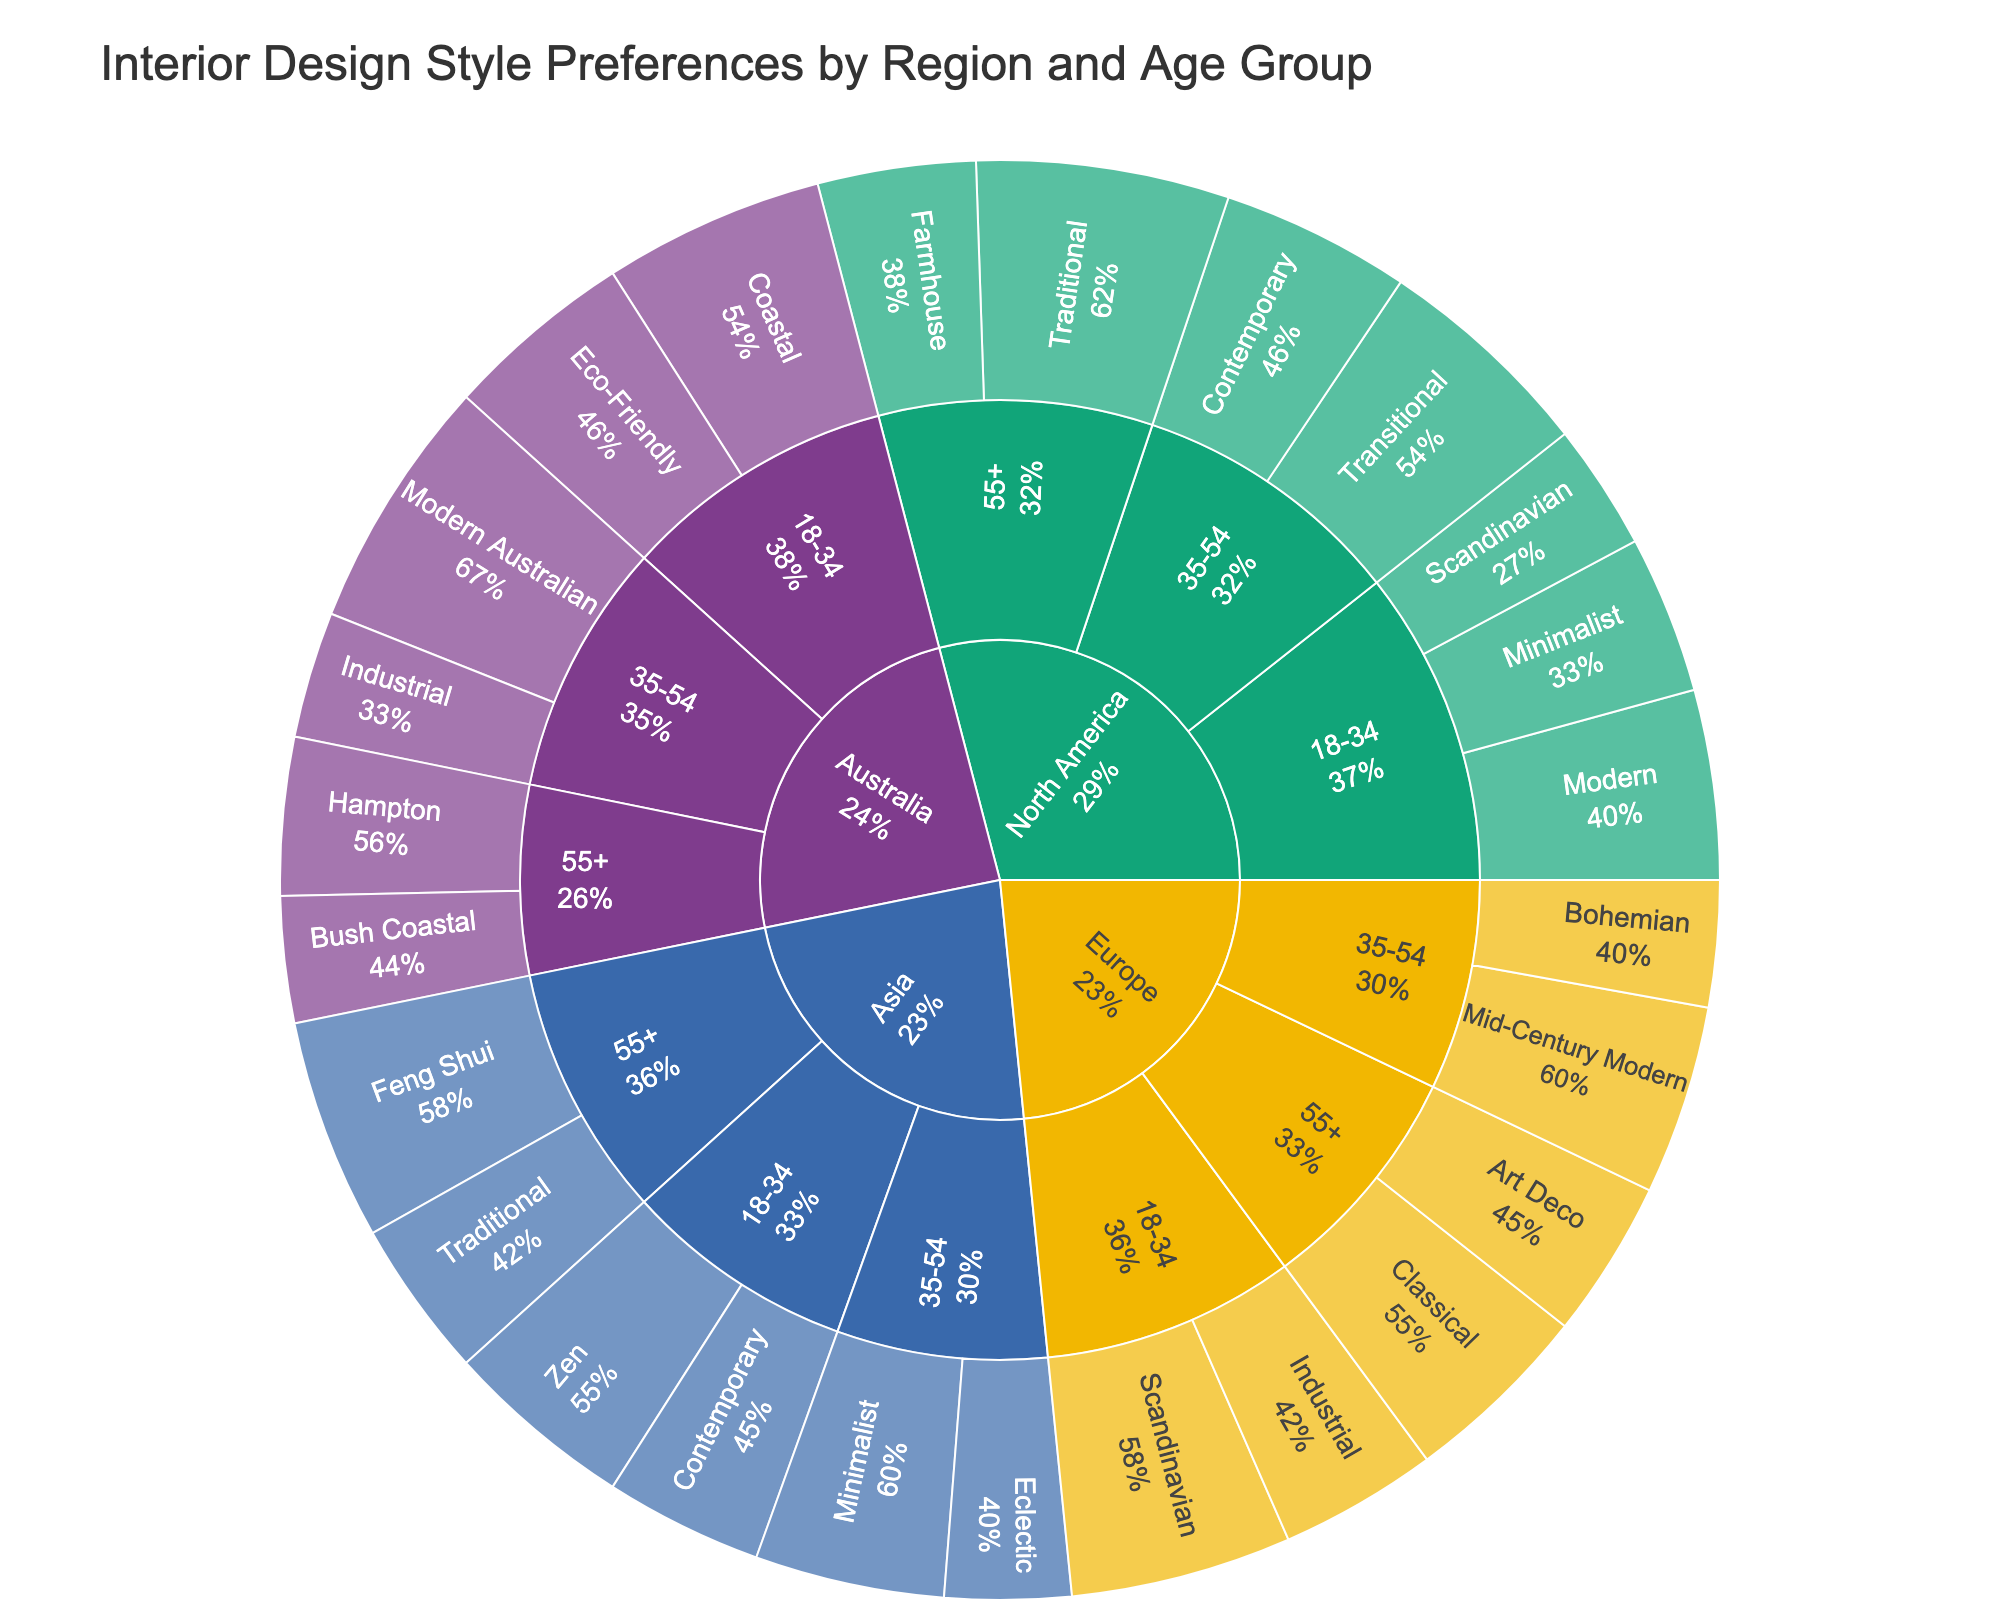Which region has the highest preference for Minimalist style among the 18-34 age group? To find this, locate the 'Minimalist' style within each region's 18-34 age group. North America shows a higher preference (25) compared to Asia (30 but under 35-54 age group) and Australia (not listed). Therefore, North America has the highest preference among the listed data for this age group and style.
Answer: North America What percentage of the North American 35-54 age group prefers Transitional style? Find the preference for 'Transitional' style within the North American 35-54 age group (35). Then, sum up all preferences in the North American 35-54 category (35 + 30 = 65). The percentage is calculated as (35/65) * 100 = 53.8%.
Answer: 53.8% Which style has the highest preference among the 55+ age group in Europe? Look at the styles within Europe's 55+ age group. 'Classical' has a preference of 30, and 'Art Deco' has 25. Therefore, 'Classical' has the highest preference.
Answer: Classical What is the total preference for Scandinavian style in both Europe and North America for the 18-34 age group? Find the preference for 'Scandinavian' style within the 18-34 age group in both regions. Europe shows 35 and North America shows 20. Summing these preferences gives 35 + 20 = 55.
Answer: 55 How does the preference for Modern Australian among 35-54 age group in Australia compare to the preference for Traditional among 55+ age group in North America? Look at 'Modern Australian' for Australia's 35-54 age group (40) and 'Traditional' for North America's 55+ age group (40). Both preferences are equal.
Answer: They are equal What style has the lowest preference among all styles listed for the North American 18-34 age group? Compare the preferences for all styles within North America's 18-34 age group: Modern (30), Minimalist (25), and Scandinavian (20). 'Scandinavian' has the lowest preference.
Answer: Scandinavian What's the total preference for Zen and Feng Shui styles combined in Asia? Locate the preferences for 'Zen' (30) and 'Feng Shui' (35) styles within Asia. Adding them gives 30 + 35 = 65.
Answer: 65 Which age group in Australia has the highest total preference for all listed styles combined? Total the preferences for each listed style in the age groups of Australia. 
18-34: Coastal (35) + Eco-Friendly (30) = 65
35-54: Modern Australian (40) + Industrial (20) = 60
55+: Hampton (25) + Bush Coastal (20) = 45
The 18-34 age group has the highest total preference.
Answer: 18-34 In Asia, which style is most preferred by the 35-54 age group? Look at styles within Asia's 35-54 age group: Eclectic (20) and Minimalist (30). 'Minimalist' has the higher preference.
Answer: Minimalist 